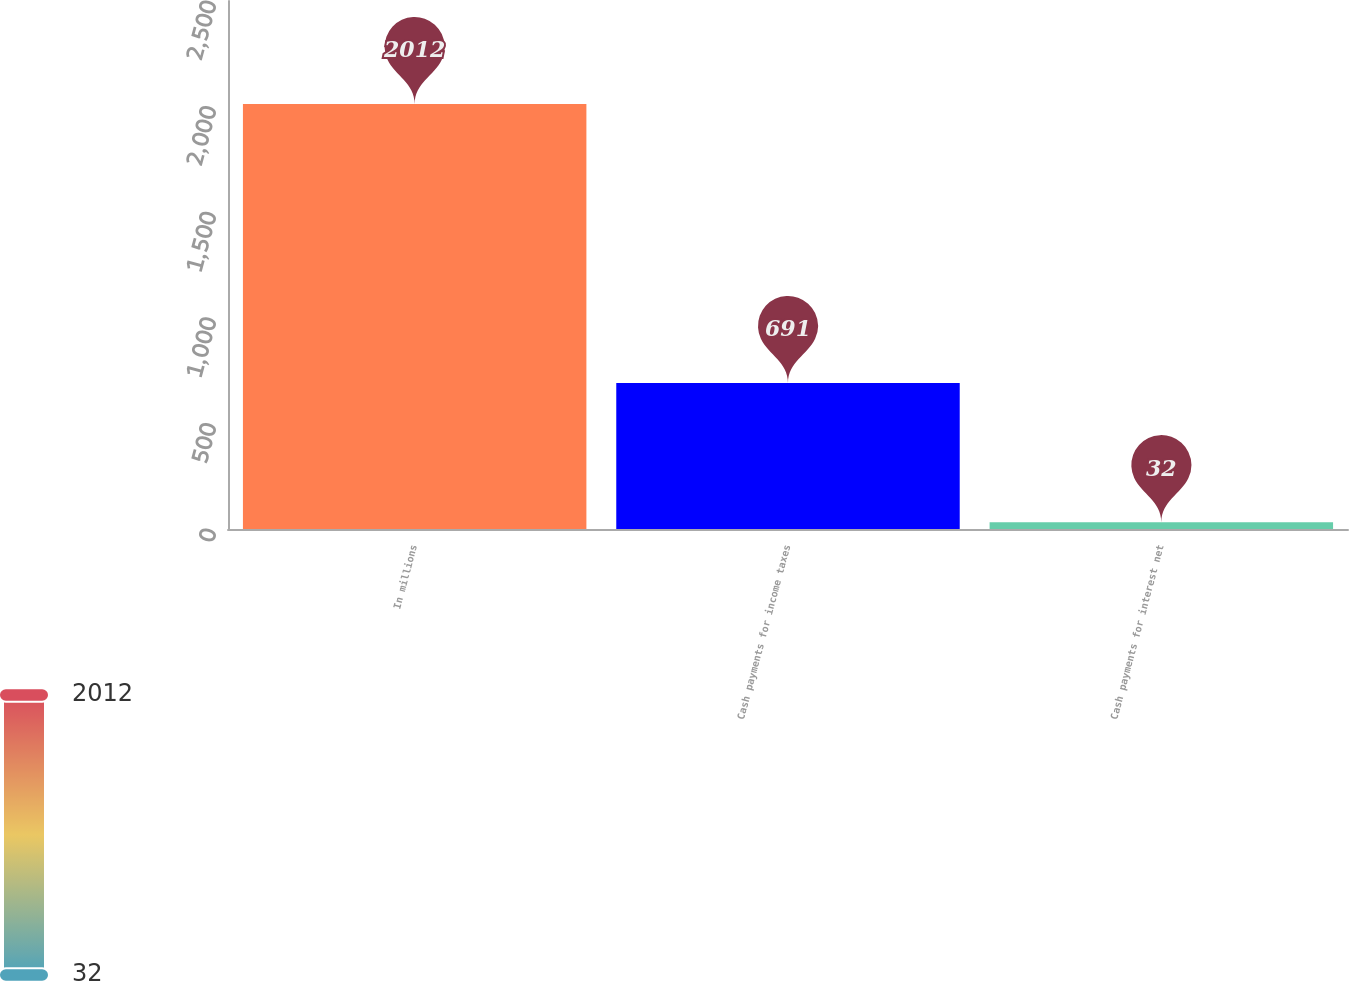Convert chart to OTSL. <chart><loc_0><loc_0><loc_500><loc_500><bar_chart><fcel>In millions<fcel>Cash payments for income taxes<fcel>Cash payments for interest net<nl><fcel>2012<fcel>691<fcel>32<nl></chart> 